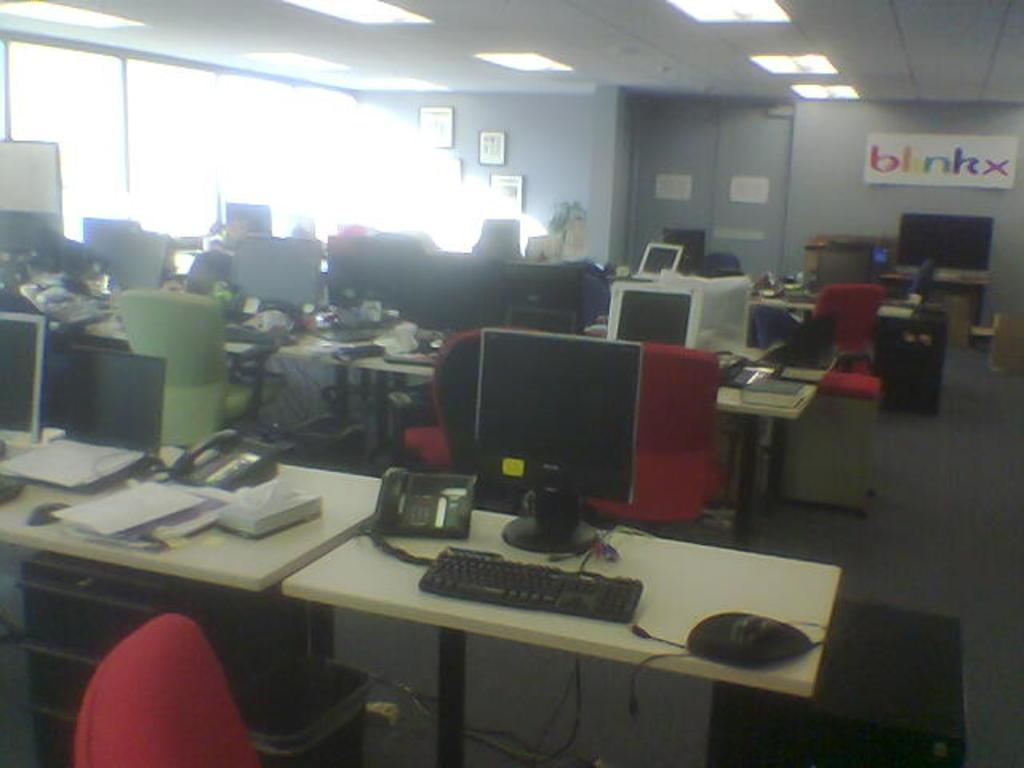<image>
Render a clear and concise summary of the photo. An office with many desks and computers and a sign on the wall that says "blinkx". 